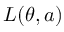<formula> <loc_0><loc_0><loc_500><loc_500>L ( \theta , a )</formula> 